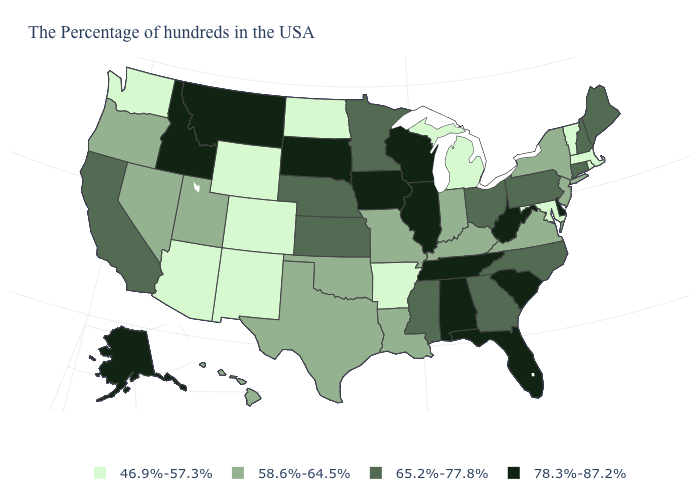Does Alaska have a higher value than Maine?
Keep it brief. Yes. How many symbols are there in the legend?
Be succinct. 4. What is the value of California?
Short answer required. 65.2%-77.8%. Does Montana have the lowest value in the West?
Answer briefly. No. Among the states that border Iowa , does Illinois have the lowest value?
Keep it brief. No. Among the states that border Maryland , does Virginia have the lowest value?
Give a very brief answer. Yes. What is the value of Missouri?
Be succinct. 58.6%-64.5%. Does Washington have the lowest value in the USA?
Write a very short answer. Yes. Name the states that have a value in the range 65.2%-77.8%?
Be succinct. Maine, New Hampshire, Connecticut, Pennsylvania, North Carolina, Ohio, Georgia, Mississippi, Minnesota, Kansas, Nebraska, California. Which states have the lowest value in the South?
Answer briefly. Maryland, Arkansas. What is the lowest value in states that border Kansas?
Short answer required. 46.9%-57.3%. What is the lowest value in the South?
Keep it brief. 46.9%-57.3%. Among the states that border North Carolina , does Virginia have the lowest value?
Write a very short answer. Yes. Does the first symbol in the legend represent the smallest category?
Give a very brief answer. Yes. What is the lowest value in the USA?
Keep it brief. 46.9%-57.3%. 